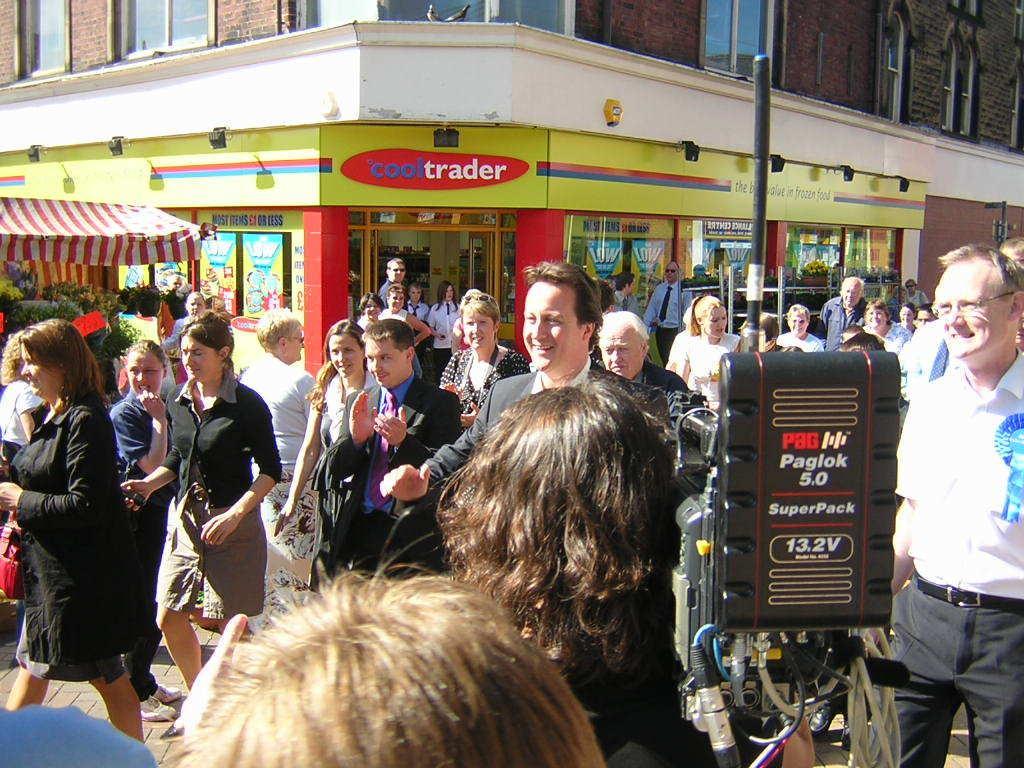In one or two sentences, can you explain what this image depicts? In this picture there are people and we can see electrical device on pole. In the background of the image we can see building, windows, tent and posters. 